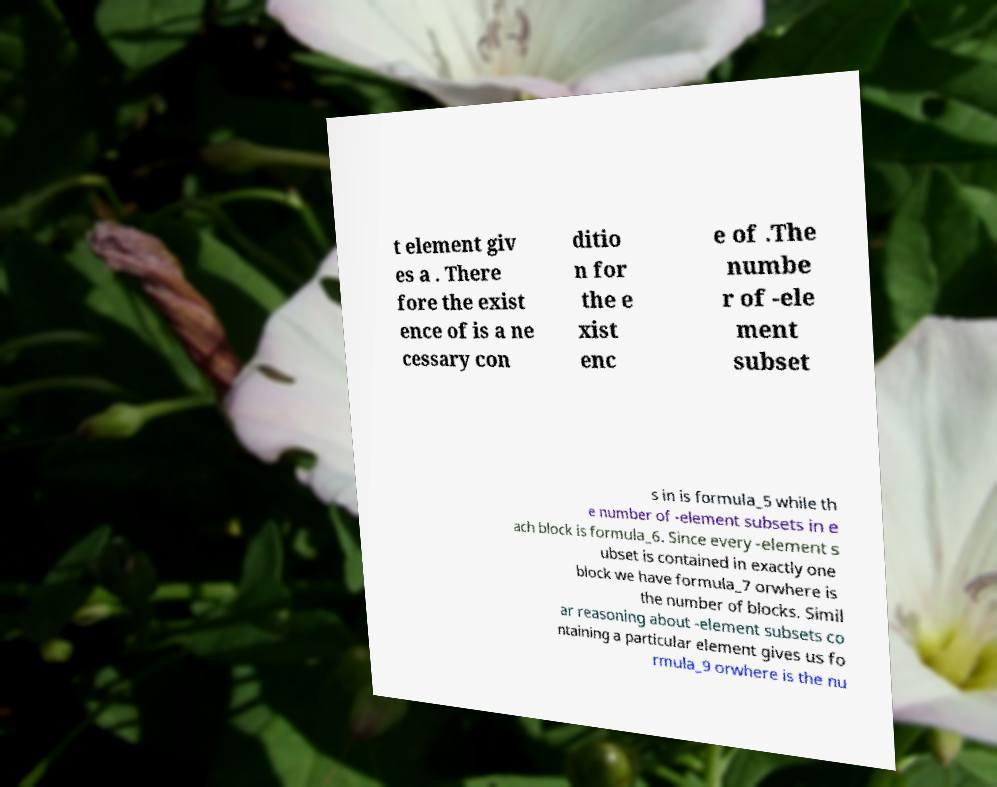For documentation purposes, I need the text within this image transcribed. Could you provide that? t element giv es a . There fore the exist ence of is a ne cessary con ditio n for the e xist enc e of .The numbe r of -ele ment subset s in is formula_5 while th e number of -element subsets in e ach block is formula_6. Since every -element s ubset is contained in exactly one block we have formula_7 orwhere is the number of blocks. Simil ar reasoning about -element subsets co ntaining a particular element gives us fo rmula_9 orwhere is the nu 